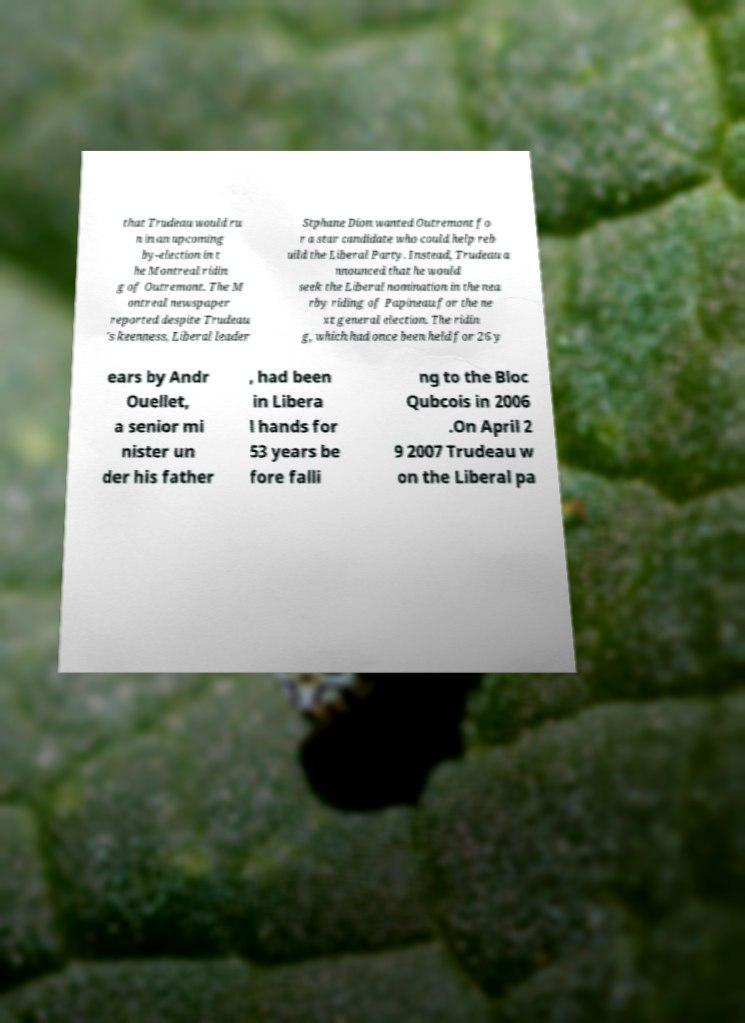For documentation purposes, I need the text within this image transcribed. Could you provide that? that Trudeau would ru n in an upcoming by-election in t he Montreal ridin g of Outremont. The M ontreal newspaper reported despite Trudeau 's keenness, Liberal leader Stphane Dion wanted Outremont fo r a star candidate who could help reb uild the Liberal Party. Instead, Trudeau a nnounced that he would seek the Liberal nomination in the nea rby riding of Papineau for the ne xt general election. The ridin g, which had once been held for 26 y ears by Andr Ouellet, a senior mi nister un der his father , had been in Libera l hands for 53 years be fore falli ng to the Bloc Qubcois in 2006 .On April 2 9 2007 Trudeau w on the Liberal pa 